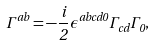Convert formula to latex. <formula><loc_0><loc_0><loc_500><loc_500>\Gamma ^ { a b } = - \frac { i } { 2 } \epsilon ^ { a b c d 0 } \Gamma _ { c d } \Gamma _ { 0 } ,</formula> 